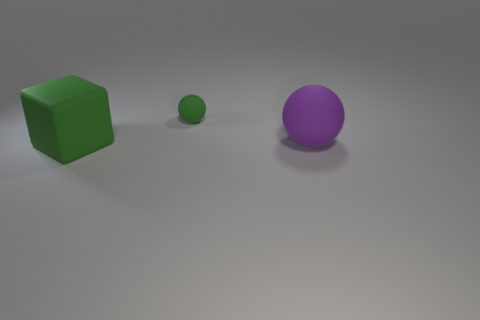Add 2 tiny matte balls. How many objects exist? 5 Subtract all cubes. How many objects are left? 2 Add 1 big rubber objects. How many big rubber objects are left? 3 Add 1 green blocks. How many green blocks exist? 2 Subtract 0 brown blocks. How many objects are left? 3 Subtract all green balls. Subtract all brown blocks. How many balls are left? 1 Subtract all large cubes. Subtract all small red rubber cylinders. How many objects are left? 2 